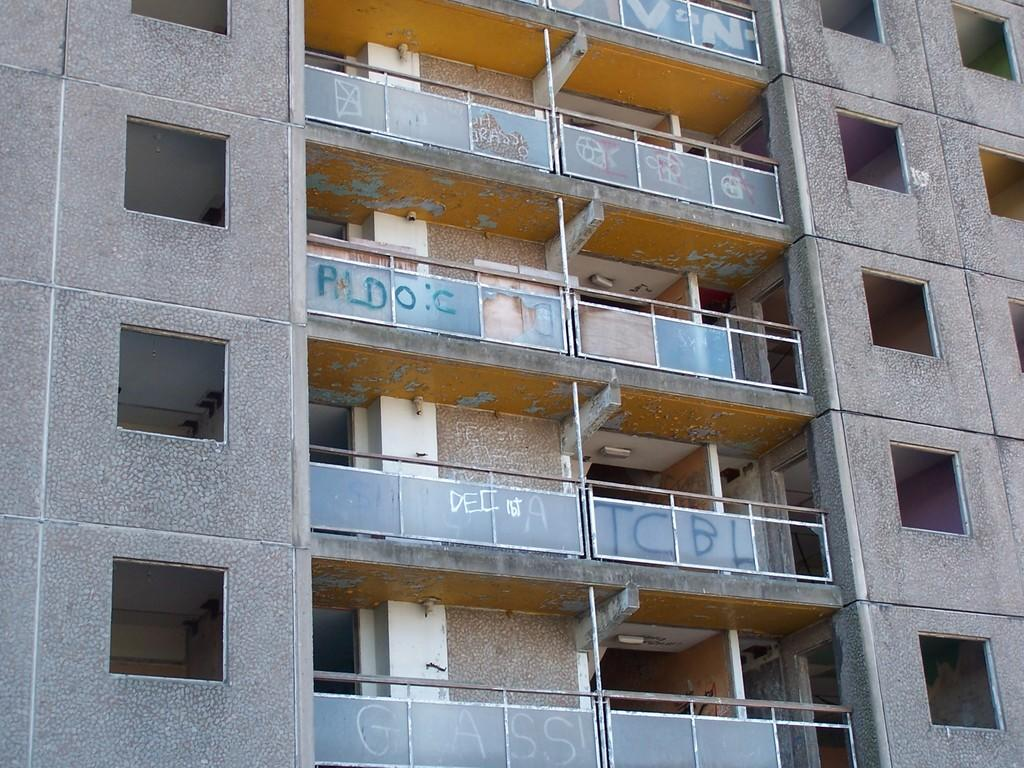Where was the image taken? The image was taken outdoors. What can be seen in the image besides the outdoor setting? There is a building in the image. What are some features of the building? The building has walls, windows, railings, and balconies. What type of gold ornament is hanging from the crayon on the record in the image? There is no gold ornament, crayon, or record present in the image. 